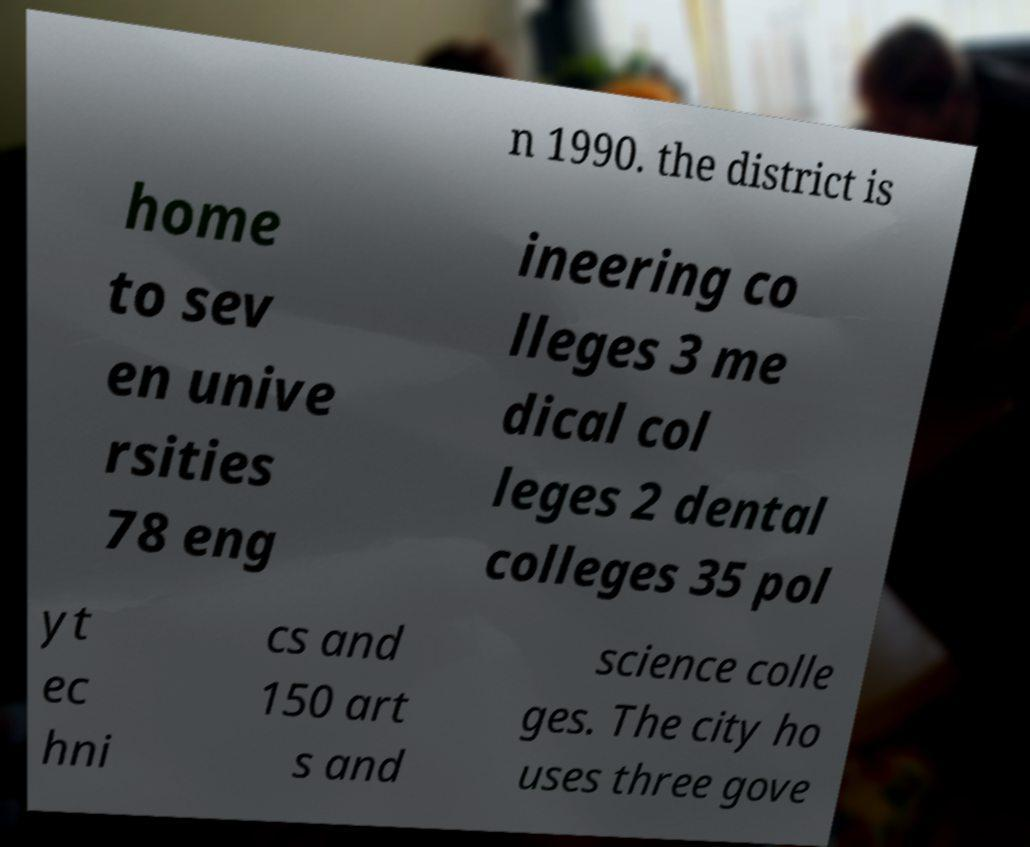What messages or text are displayed in this image? I need them in a readable, typed format. n 1990. the district is home to sev en unive rsities 78 eng ineering co lleges 3 me dical col leges 2 dental colleges 35 pol yt ec hni cs and 150 art s and science colle ges. The city ho uses three gove 